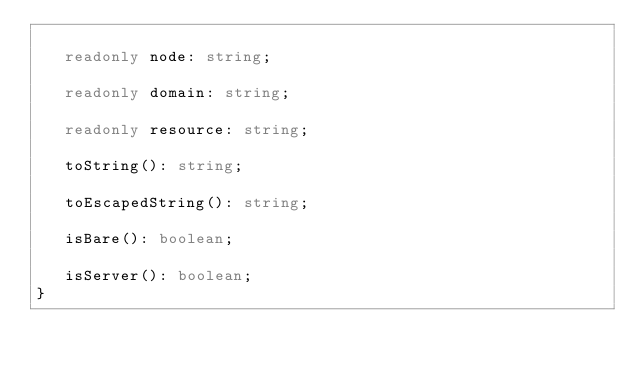<code> <loc_0><loc_0><loc_500><loc_500><_TypeScript_>
   readonly node: string;

   readonly domain: string;

   readonly resource: string;

   toString(): string;

   toEscapedString(): string;

   isBare(): boolean;

   isServer(): boolean;
}
</code> 